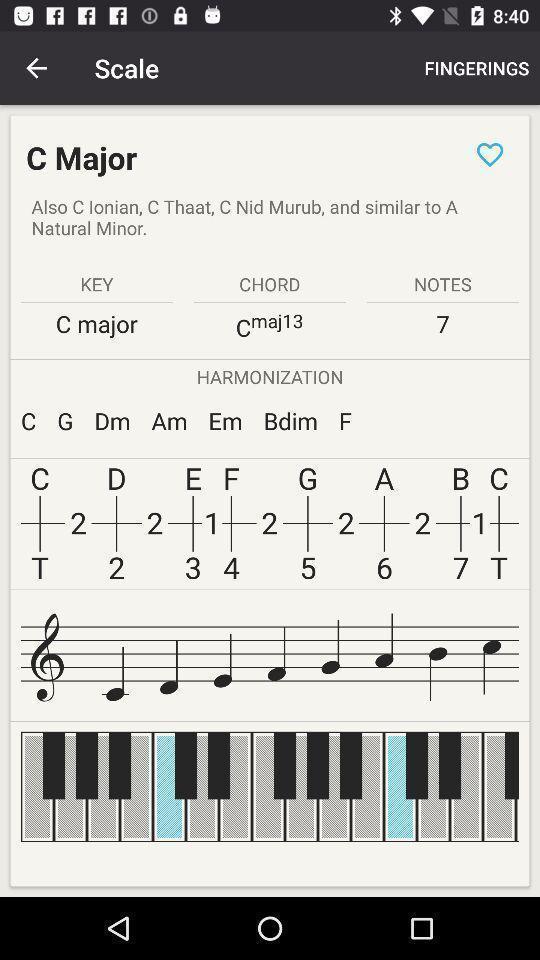Give me a narrative description of this picture. Screen showing scale in an musical instrument application. 